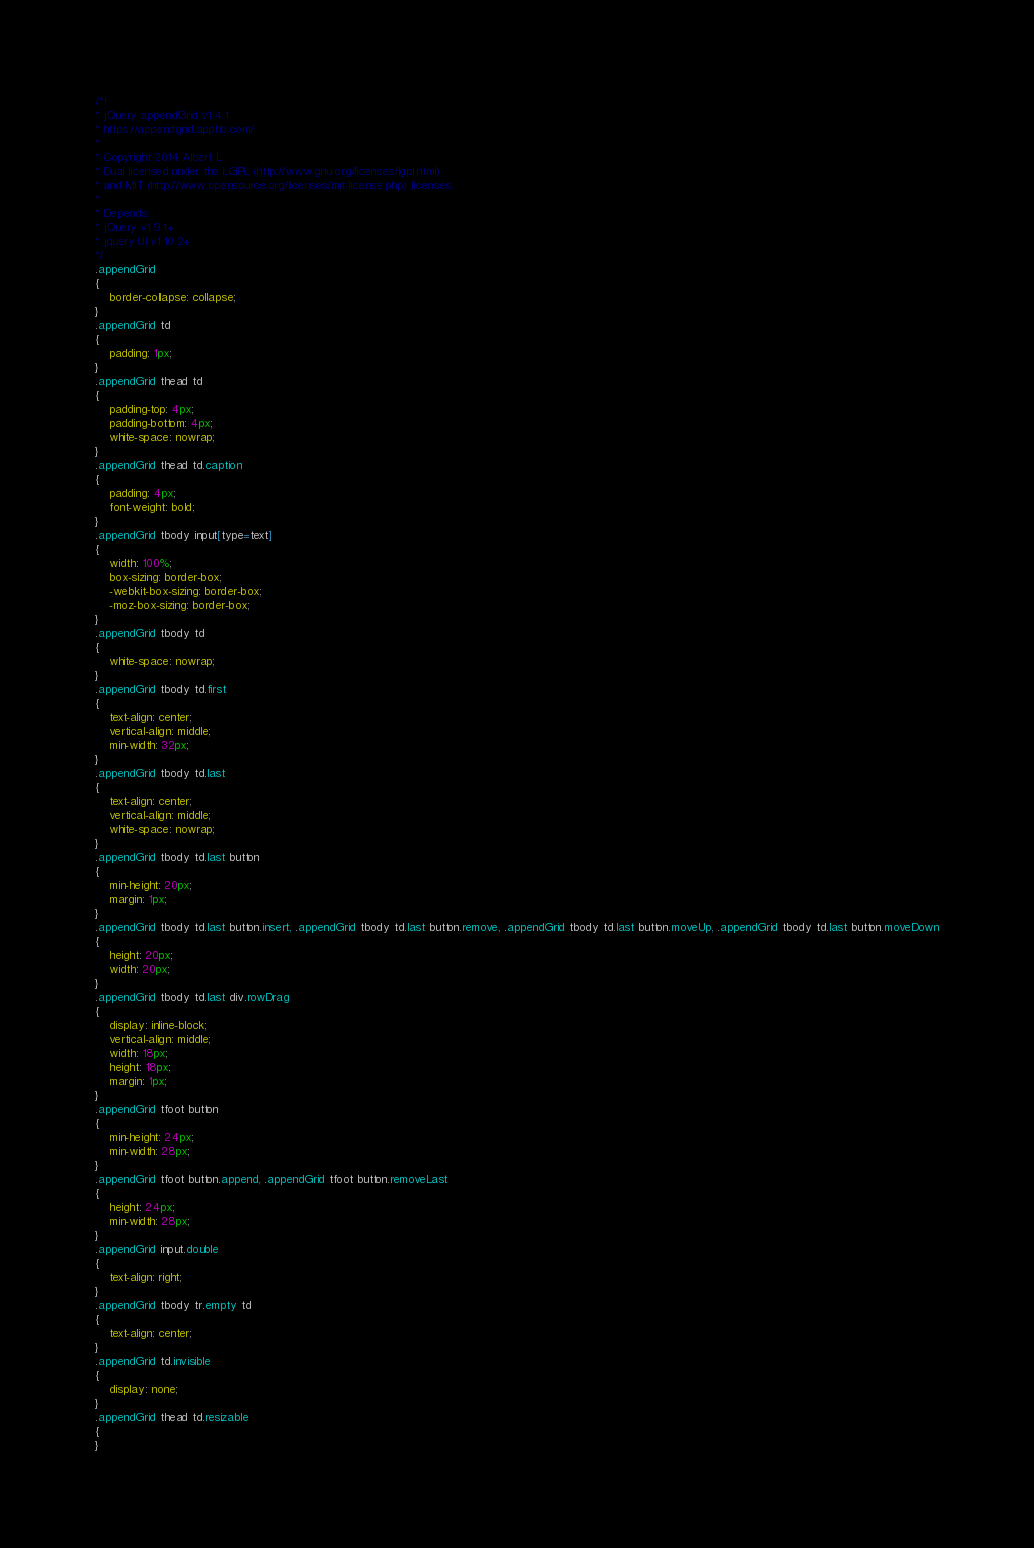<code> <loc_0><loc_0><loc_500><loc_500><_CSS_>/*!
* jQuery appendGrid v1.4.1
* https://appendgrid.apphb.com/
*
* Copyright 2014 Albert L.
* Dual licensed under the LGPL (http://www.gnu.org/licenses/lgpl.html)
* and MIT (http://www.opensource.org/licenses/mit-license.php) licenses.
*
* Depends:
* jQuery v1.9.1+
* jquery UI v1.10.2+
*/
.appendGrid
{
    border-collapse: collapse;
}
.appendGrid td
{
    padding: 1px;
}
.appendGrid thead td
{
    padding-top: 4px;
    padding-bottom: 4px;
    white-space: nowrap;
}
.appendGrid thead td.caption
{
    padding: 4px;
    font-weight: bold;
}
.appendGrid tbody input[type=text]
{
    width: 100%;
    box-sizing: border-box;
    -webkit-box-sizing: border-box;
    -moz-box-sizing: border-box;
}
.appendGrid tbody td
{
    white-space: nowrap;
}
.appendGrid tbody td.first
{
    text-align: center;
    vertical-align: middle;
    min-width: 32px;
}
.appendGrid tbody td.last
{
    text-align: center;
    vertical-align: middle;
    white-space: nowrap;
}
.appendGrid tbody td.last button
{
	min-height: 20px;
    margin: 1px;
}
.appendGrid tbody td.last button.insert, .appendGrid tbody td.last button.remove, .appendGrid tbody td.last button.moveUp, .appendGrid tbody td.last button.moveDown
{
	height: 20px;
    width: 20px;
}
.appendGrid tbody td.last div.rowDrag
{
    display: inline-block;
    vertical-align: middle;
    width: 18px;
    height: 18px;
    margin: 1px;
}
.appendGrid tfoot button
{
    min-height: 24px;
    min-width: 28px;
}
.appendGrid tfoot button.append, .appendGrid tfoot button.removeLast
{
    height: 24px;
    min-width: 28px;
}
.appendGrid input.double
{
    text-align: right;
}
.appendGrid tbody tr.empty td
{
	text-align: center;
}
.appendGrid td.invisible
{
	display: none;
}
.appendGrid thead td.resizable
{
}
</code> 